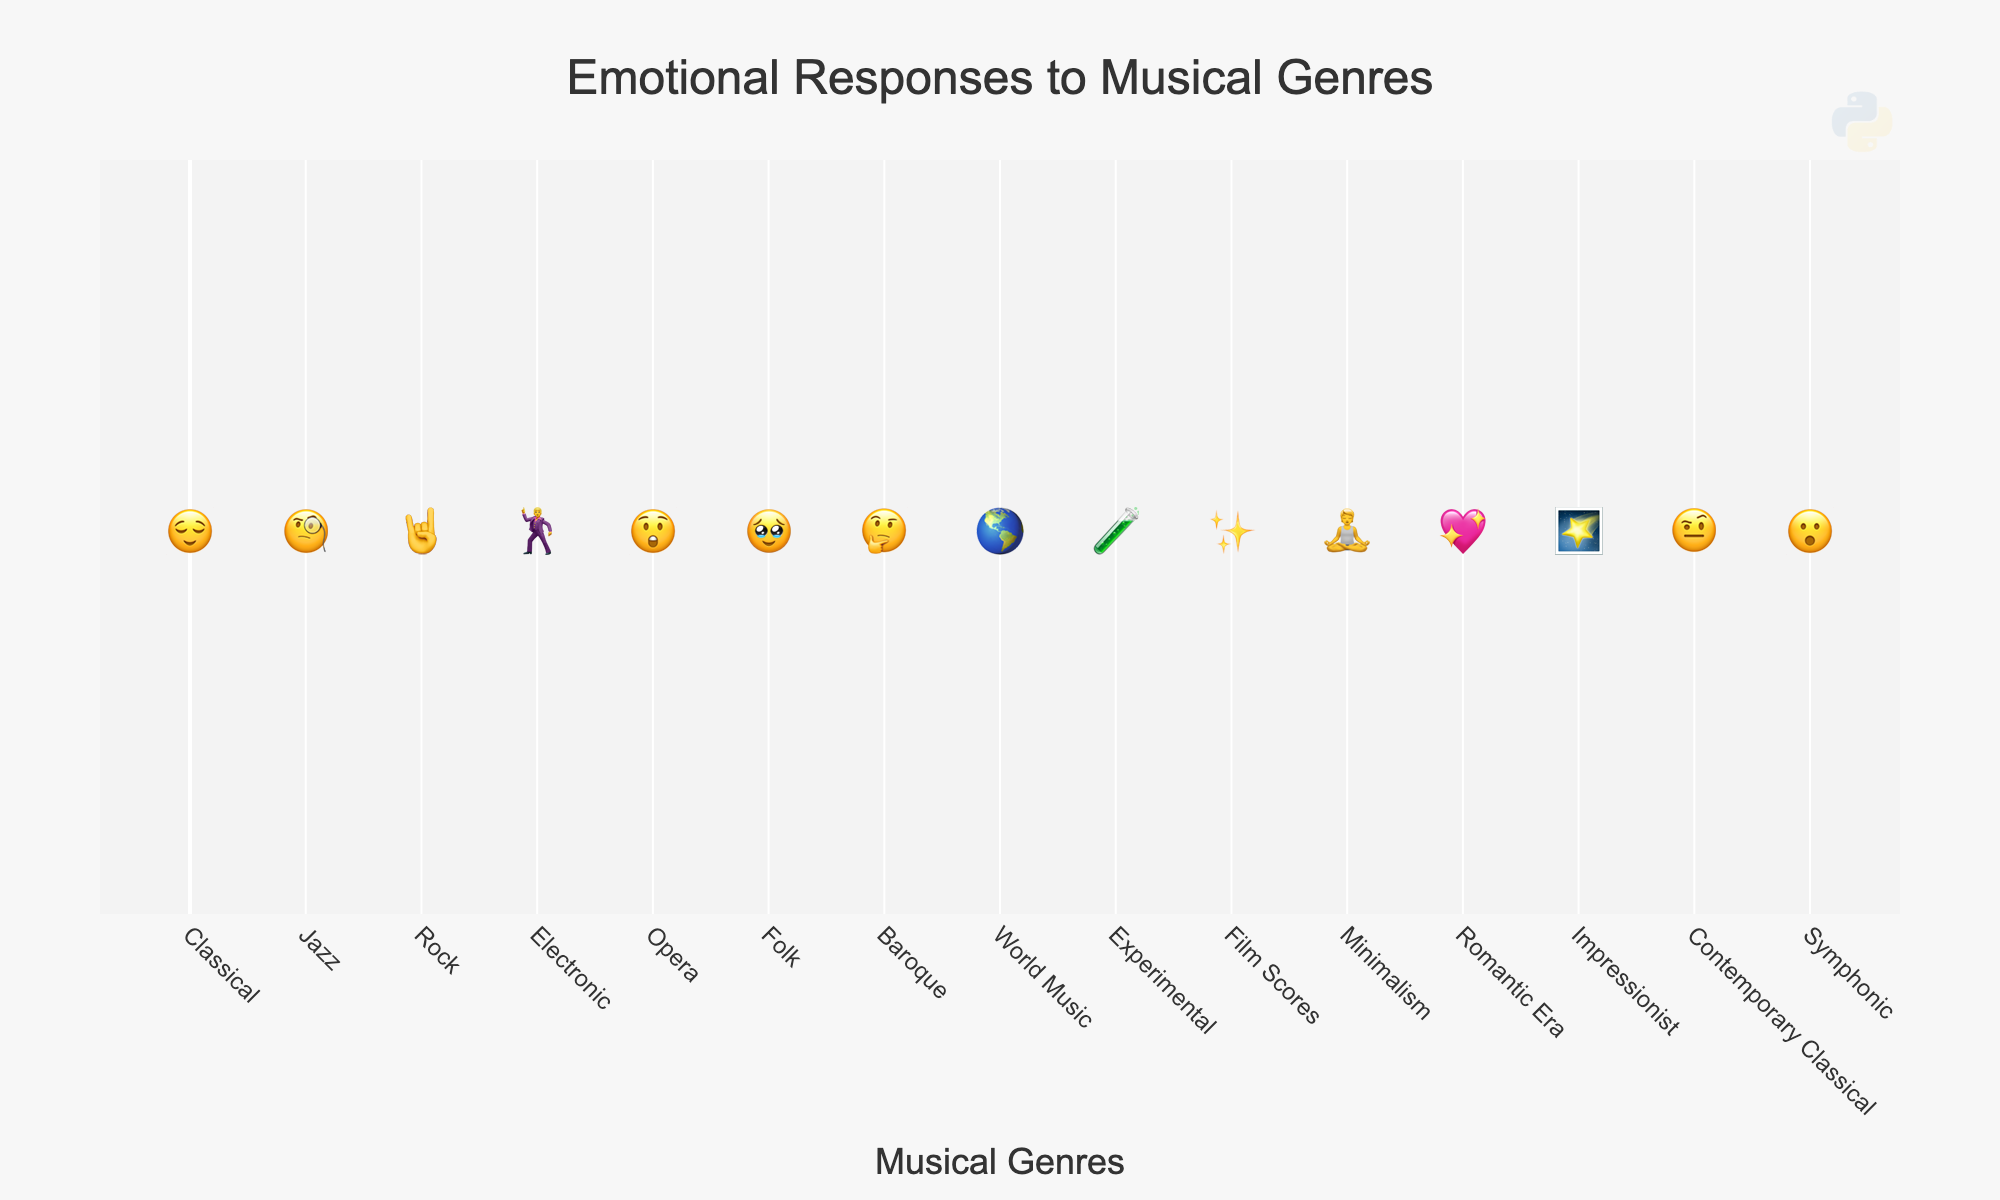What's the title of the figure? The title is usually displayed prominently at the top of the figure, stating the main topic or the type of data visualized. In this figure, the title is "Emotional Responses to Musical Genres".
Answer: Emotional Responses to Musical Genres How many musical genres are represented in the figure? To determine the number of musical genres, you can count the distinct genres displayed along the x-axis. There are 15 musical genres listed.
Answer: 15 What emotion is associated with the genre 'Rock'? Each genre is paired with an emoji that represents an emotion. For Rock, the genre is represented with the emoji "🤘", which indicates 'Energy'.
Answer: Energy Which musical genre is paired with the emotion "Wonder"? To find this, look for the emotion "Wonder" among the listed emotions and pair it with its corresponding musical genre. 'Film Scores' is associated with the emotion "Wonder".
Answer: Film Scores Compare the emotional responses of 'Classical' and 'Jazz'. Which one indicates a more relaxed state? Analyze the emotions associated with these two genres. 'Classical' is linked with 'Serenity' (😌) and 'Jazz' with 'Sophistication' (🧐). Serenity generally indicates a more relaxed state than sophistication.
Answer: Classical What is the emotional response represented by the genre 'Electronic'? Locate 'Electronic' in the x-axis labels and check the associated emoji and its meaning. The genre 'Electronic' is paired with 'Excitement' (🕺).
Answer: Excitement Which genre represents a feeling of 'Curiosity'? Scan through the listed emotions to find 'Curiosity' and see which genre it corresponds to. 'Experimental' is associated with 'Curiosity' (🧪).
Answer: Experimental Identify the genres that are associated with 'Focus' and 'Intrigue'. Check the figure for these emotions and note the corresponding genres. 'Minimalism' is associated with 'Focus' (🧘), and 'Contemporary Classical' is associated with 'Intrigue' (🤨).
Answer: Minimalism, Contemporary Classical How are the genres 'Symphonic' and 'Opera' different in terms of their emotional responses? Examine the emoji and associated emotions for these genres. 'Symphonic' corresponds with 'Awe' (😮), while 'Opera' corresponds with 'Drama' (😲). Awe represents a feeling of profound respect or wonder, whereas drama indicates heightened emotional intensity.
Answer: Symphonic evokes 'Awe' and Opera evokes 'Drama' 